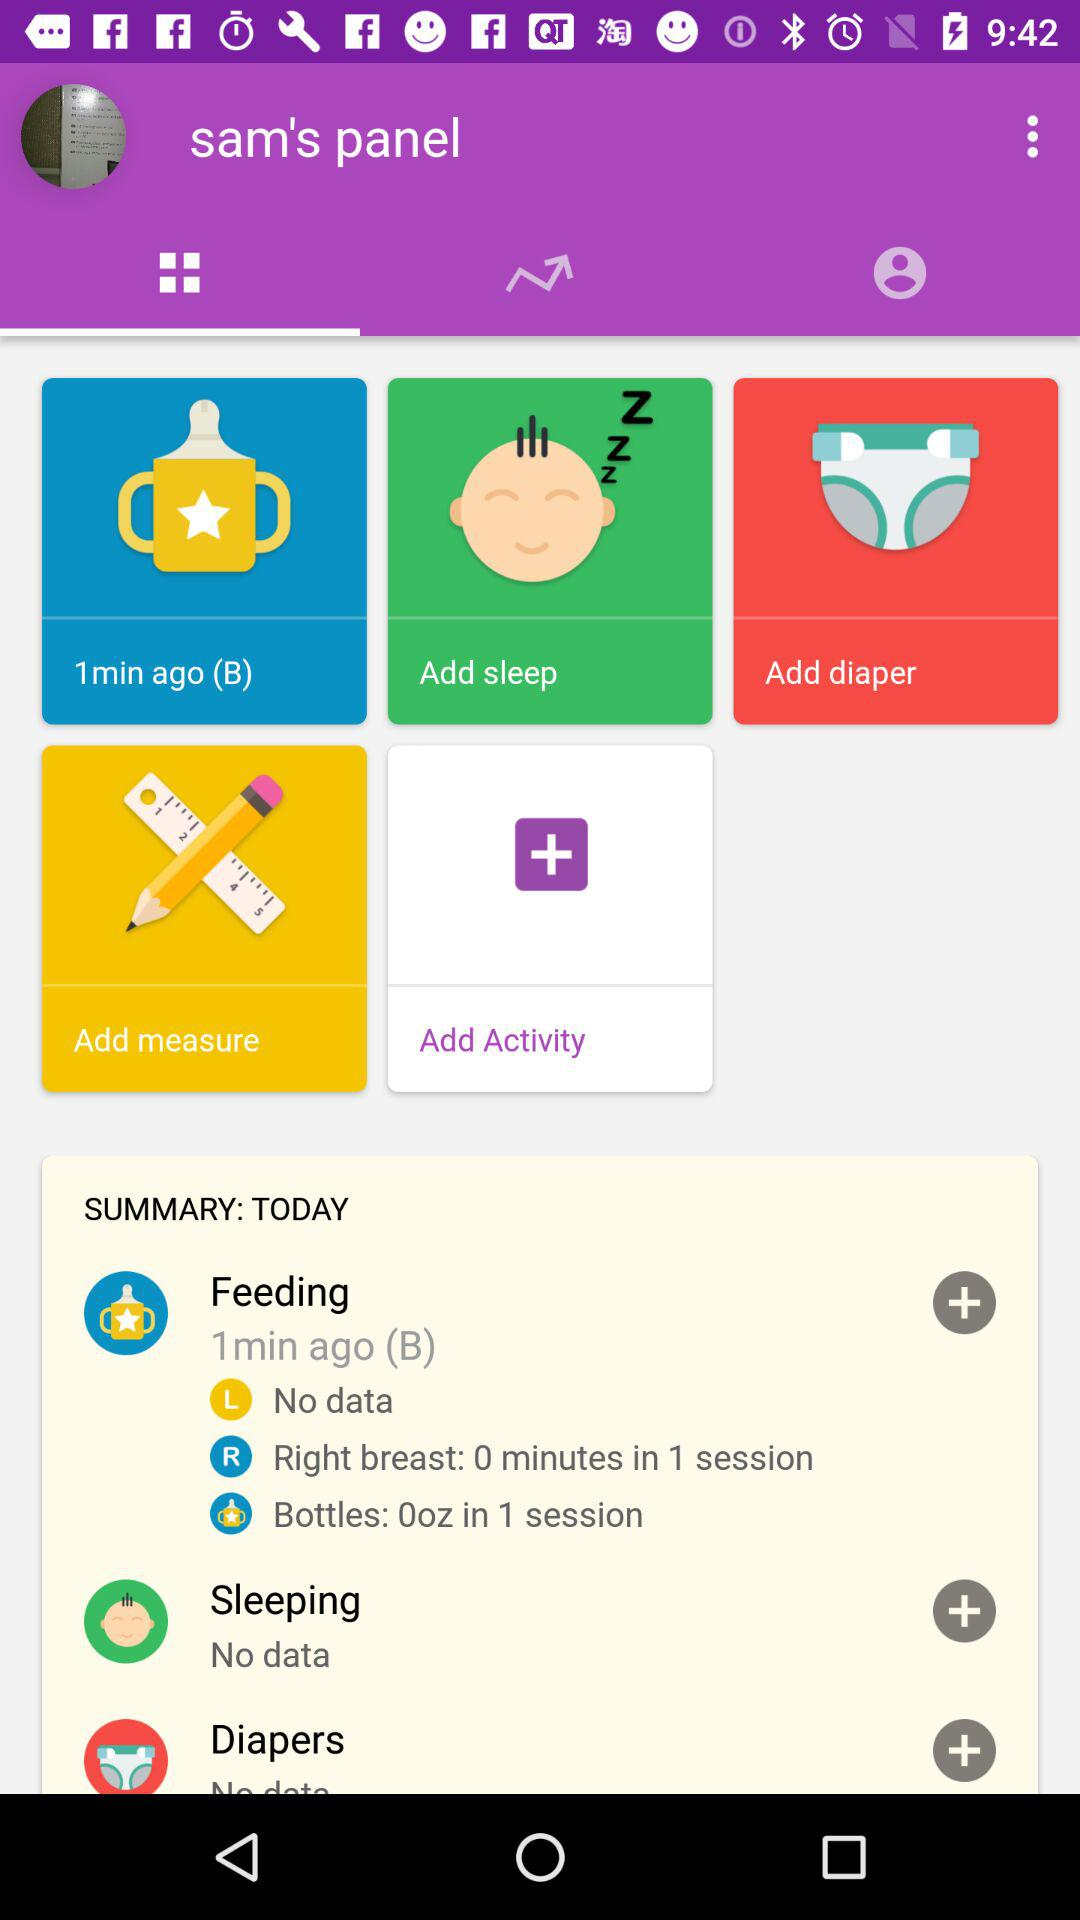What is the duration for the right breast in 1 session? The duration for the right breast is 0 minutes in 1 session. 